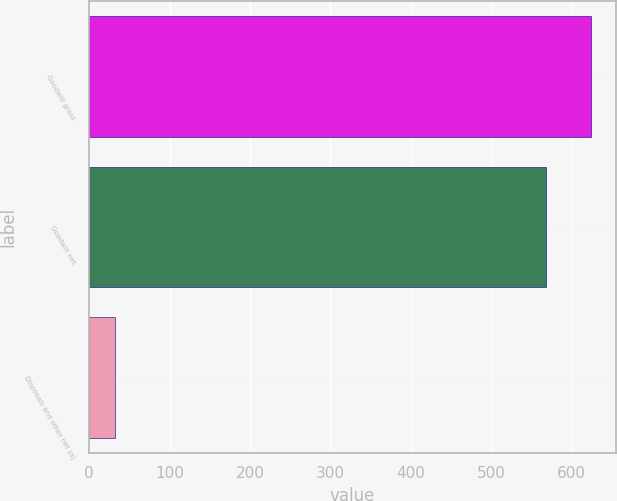Convert chart. <chart><loc_0><loc_0><loc_500><loc_500><bar_chart><fcel>Goodwill gross<fcel>Goodwill net<fcel>Disposals and other net (a)<nl><fcel>623.3<fcel>568<fcel>32<nl></chart> 